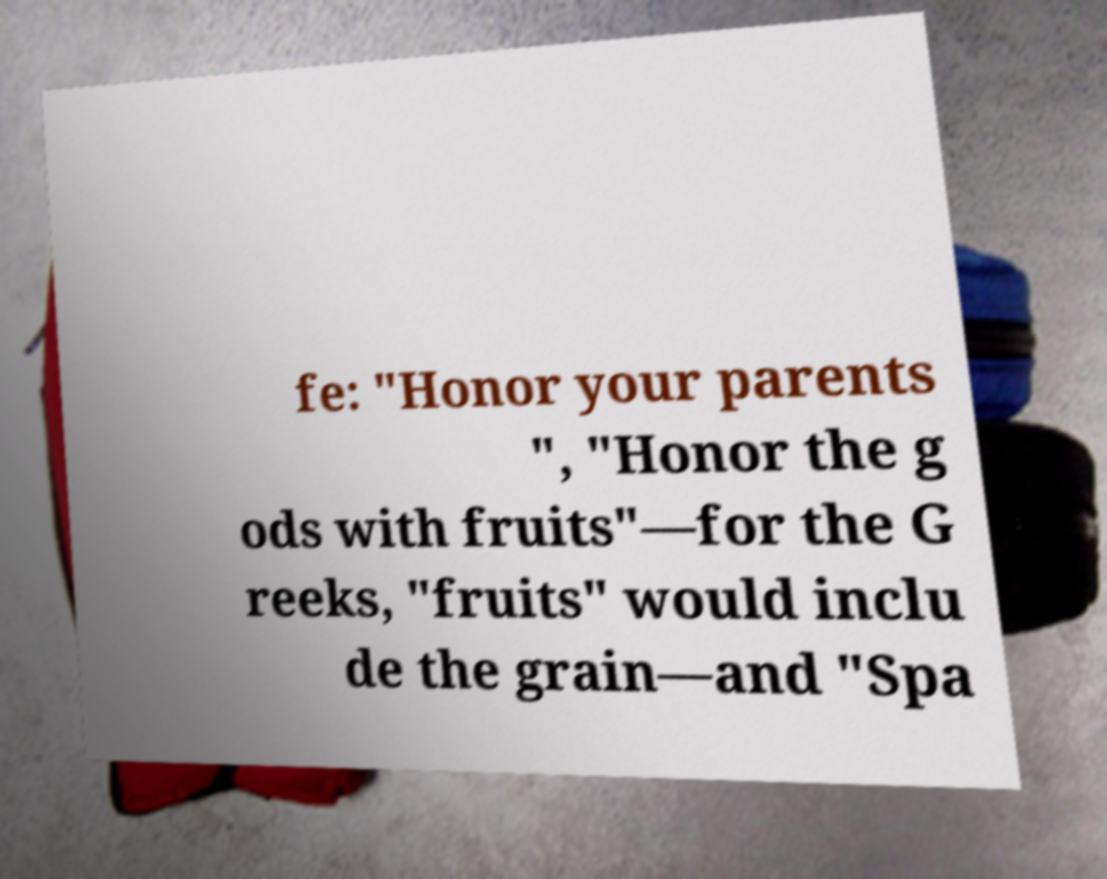Please identify and transcribe the text found in this image. fe: "Honor your parents ", "Honor the g ods with fruits"—for the G reeks, "fruits" would inclu de the grain—and "Spa 